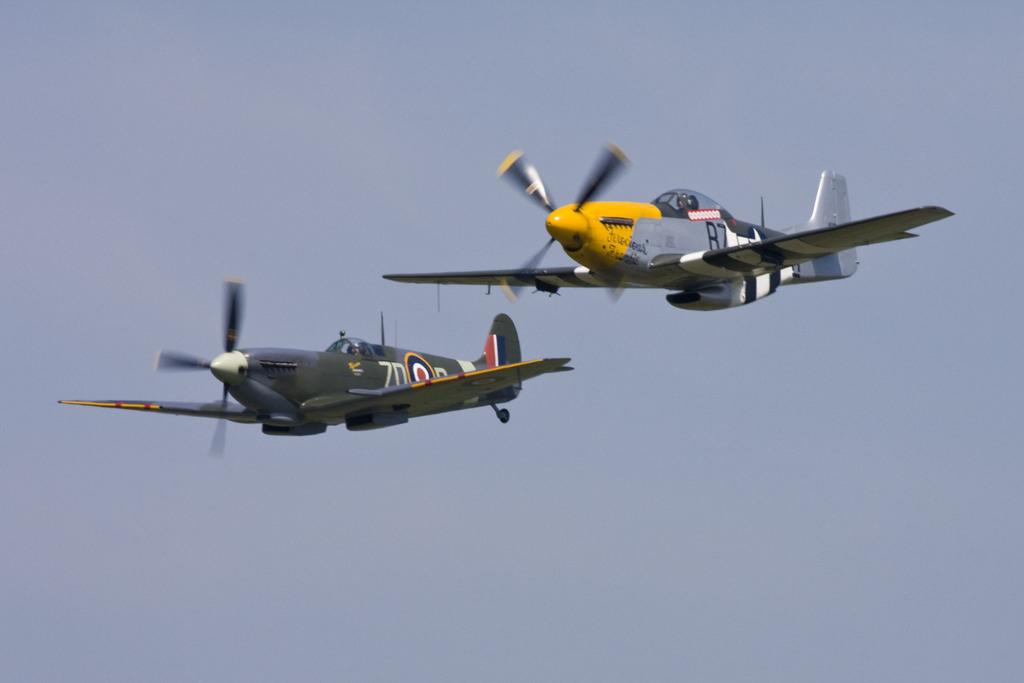What number is the gray and yellow plane?
Keep it short and to the point. 87. What number is the right plane?
Provide a short and direct response. 87. 